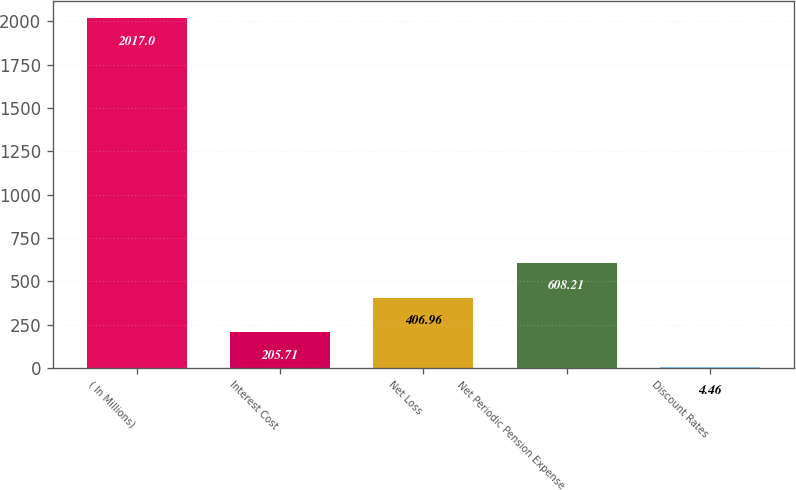<chart> <loc_0><loc_0><loc_500><loc_500><bar_chart><fcel>( In Millions)<fcel>Interest Cost<fcel>Net Loss<fcel>Net Periodic Pension Expense<fcel>Discount Rates<nl><fcel>2017<fcel>205.71<fcel>406.96<fcel>608.21<fcel>4.46<nl></chart> 